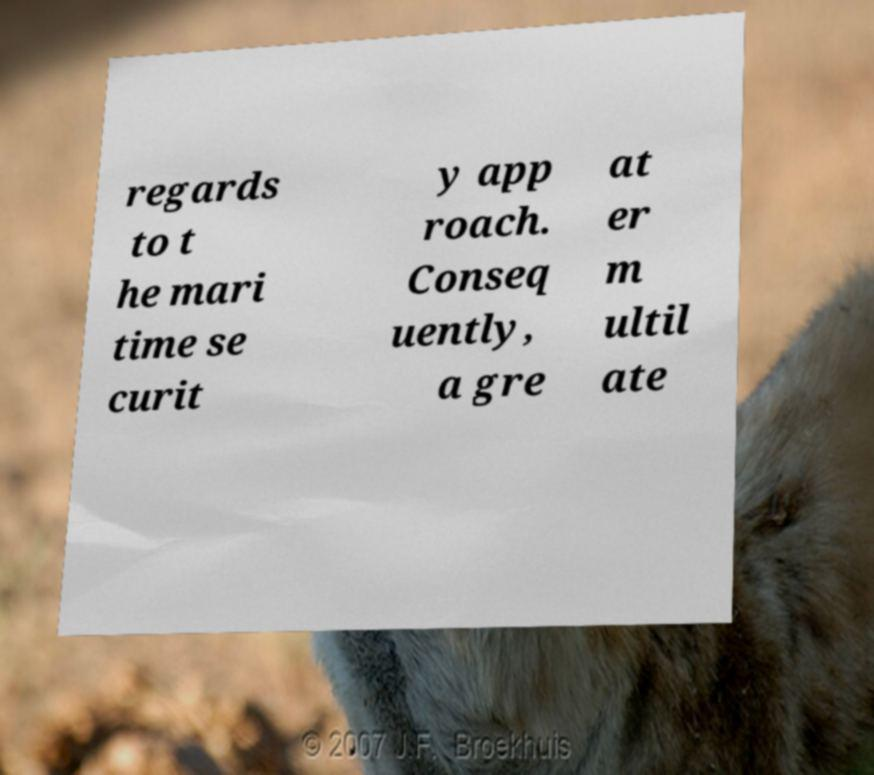Can you read and provide the text displayed in the image?This photo seems to have some interesting text. Can you extract and type it out for me? regards to t he mari time se curit y app roach. Conseq uently, a gre at er m ultil ate 